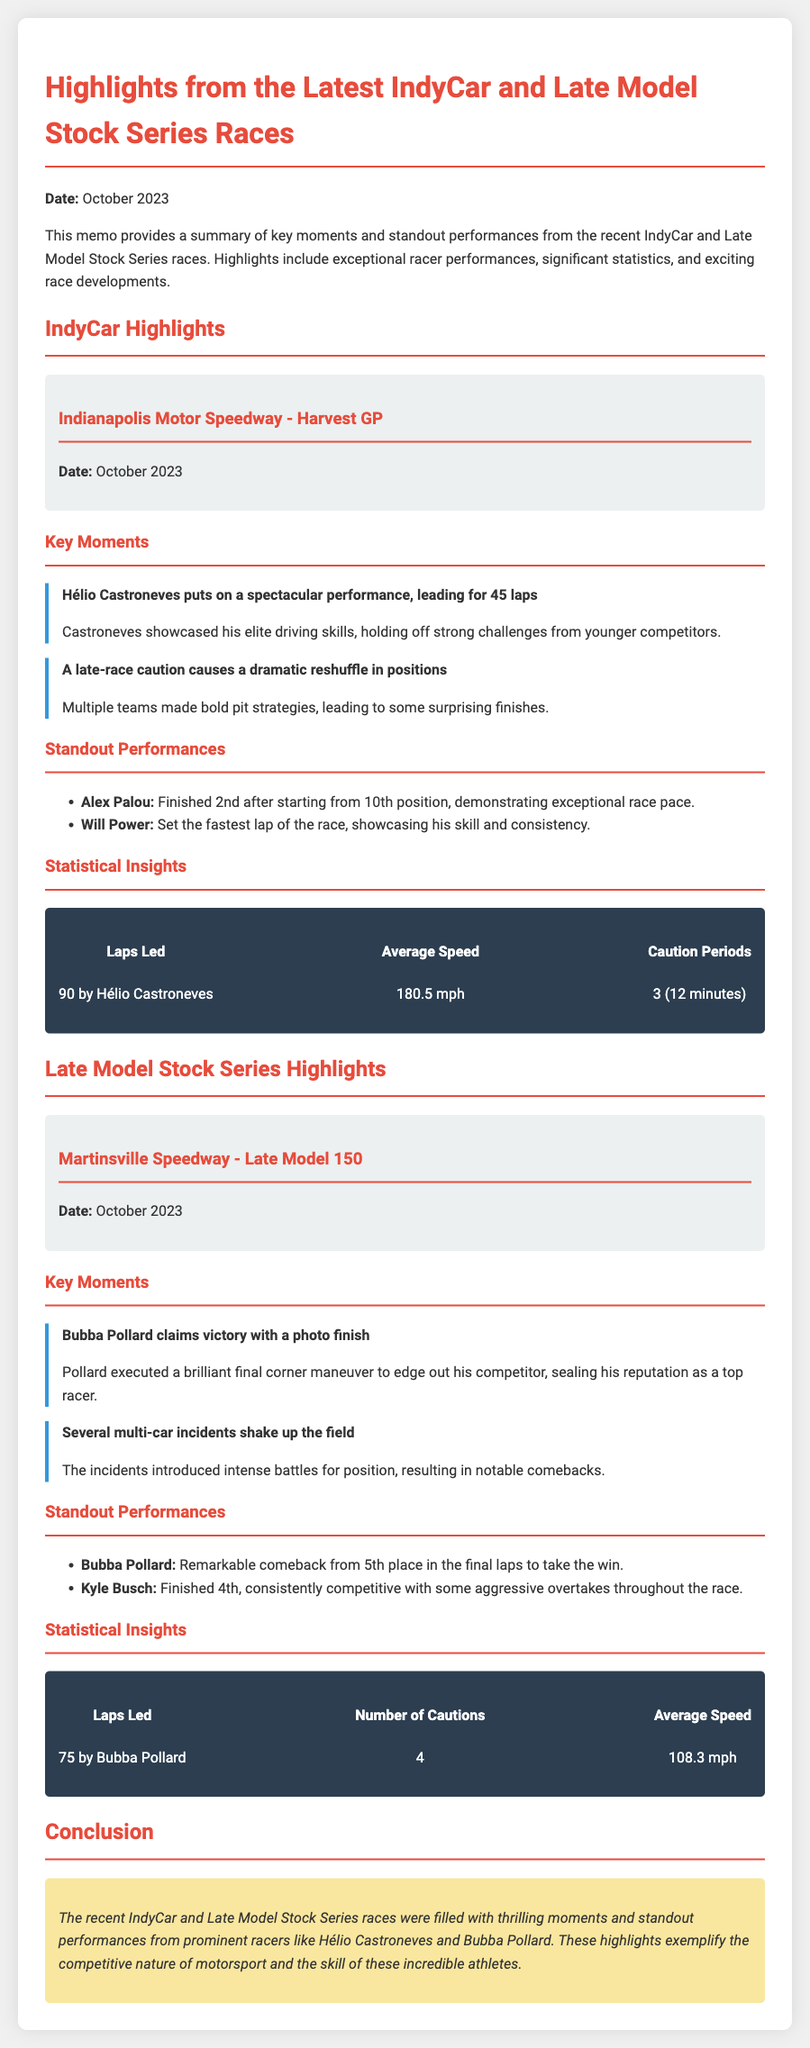what event did Hélio Castroneves compete in? Hélio Castroneves competed in the Harvest GP at Indianapolis Motor Speedway.
Answer: Harvest GP how many laps did Hélio Castroneves lead? Hélio Castroneves led 90 laps during the race.
Answer: 90 who won the Late Model 150? Bubba Pollard won the Late Model 150.
Answer: Bubba Pollard what was the average speed of the IndyCar race? The average speed of the IndyCar race was 180.5 mph.
Answer: 180.5 mph how many caution periods were there in the IndyCar race? There were 3 caution periods in the IndyCar race.
Answer: 3 what position did Alex Palou finish in? Alex Palou finished 2nd in the race.
Answer: 2nd which racer set the fastest lap in the IndyCar race? Will Power set the fastest lap of the race.
Answer: Will Power how many multi-car incidents occurred in the Late Model 150? There were several multi-car incidents in the Late Model 150.
Answer: several how many laps did Bubba Pollard lead? Bubba Pollard led 75 laps in the Late Model 150.
Answer: 75 what noteworthy skill did Bubba Pollard demonstrate? Bubba Pollard executed a brilliant final corner maneuver to win.
Answer: final corner maneuver 